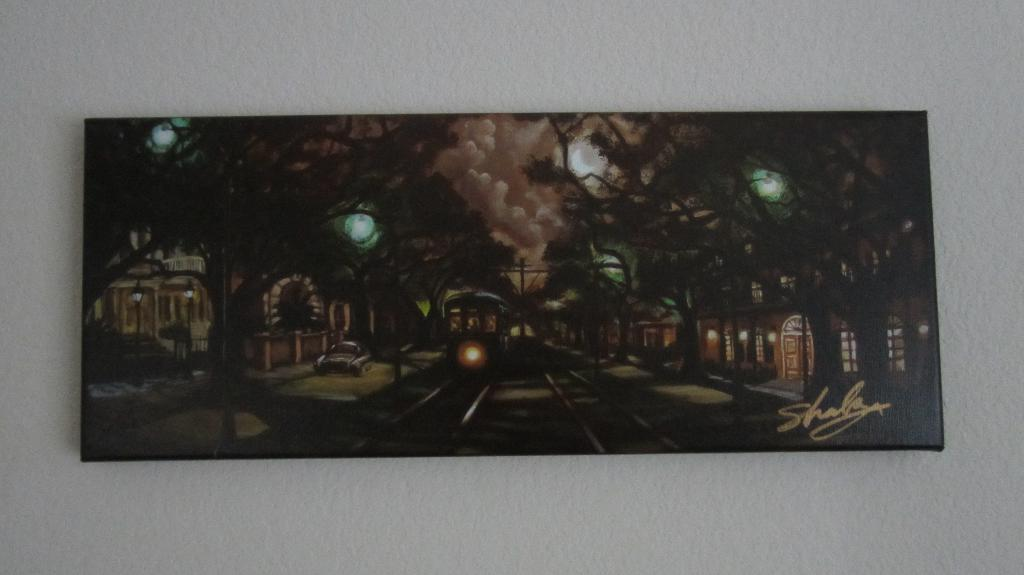<image>
Give a short and clear explanation of the subsequent image. A panoramic painting by Shala hangs on a white wall. 